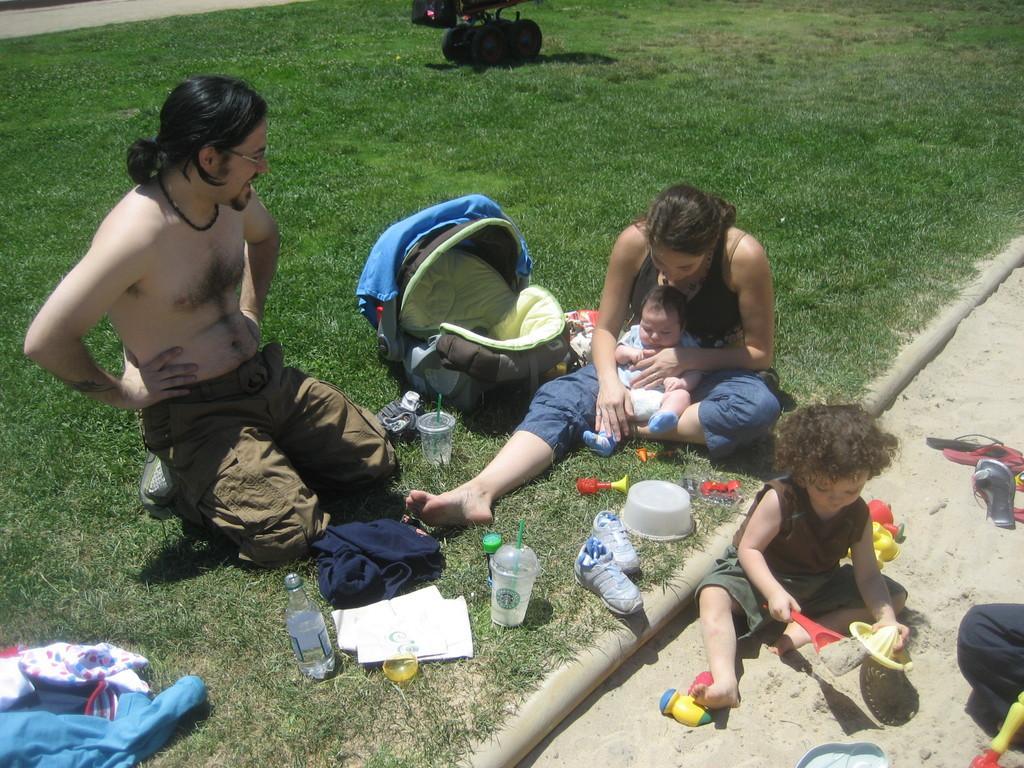Can you describe this image briefly? In this image, we can see few people, kid and baby. Here a woman is holding is holding a baby. Right side of the image, we can see a kid is playing with toys and sand. So many things and objects are placed on the grass and sand, Top of the image, we can see wheels. 